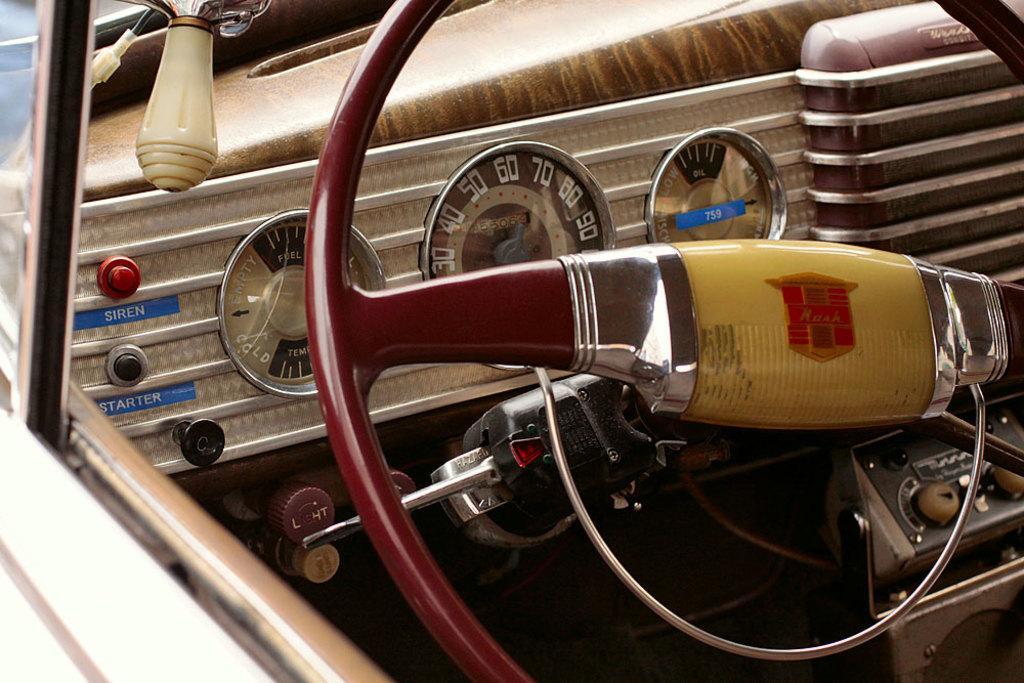Please provide a concise description of this image. In the center of the image we can see steering, indicators, horn in the car. 